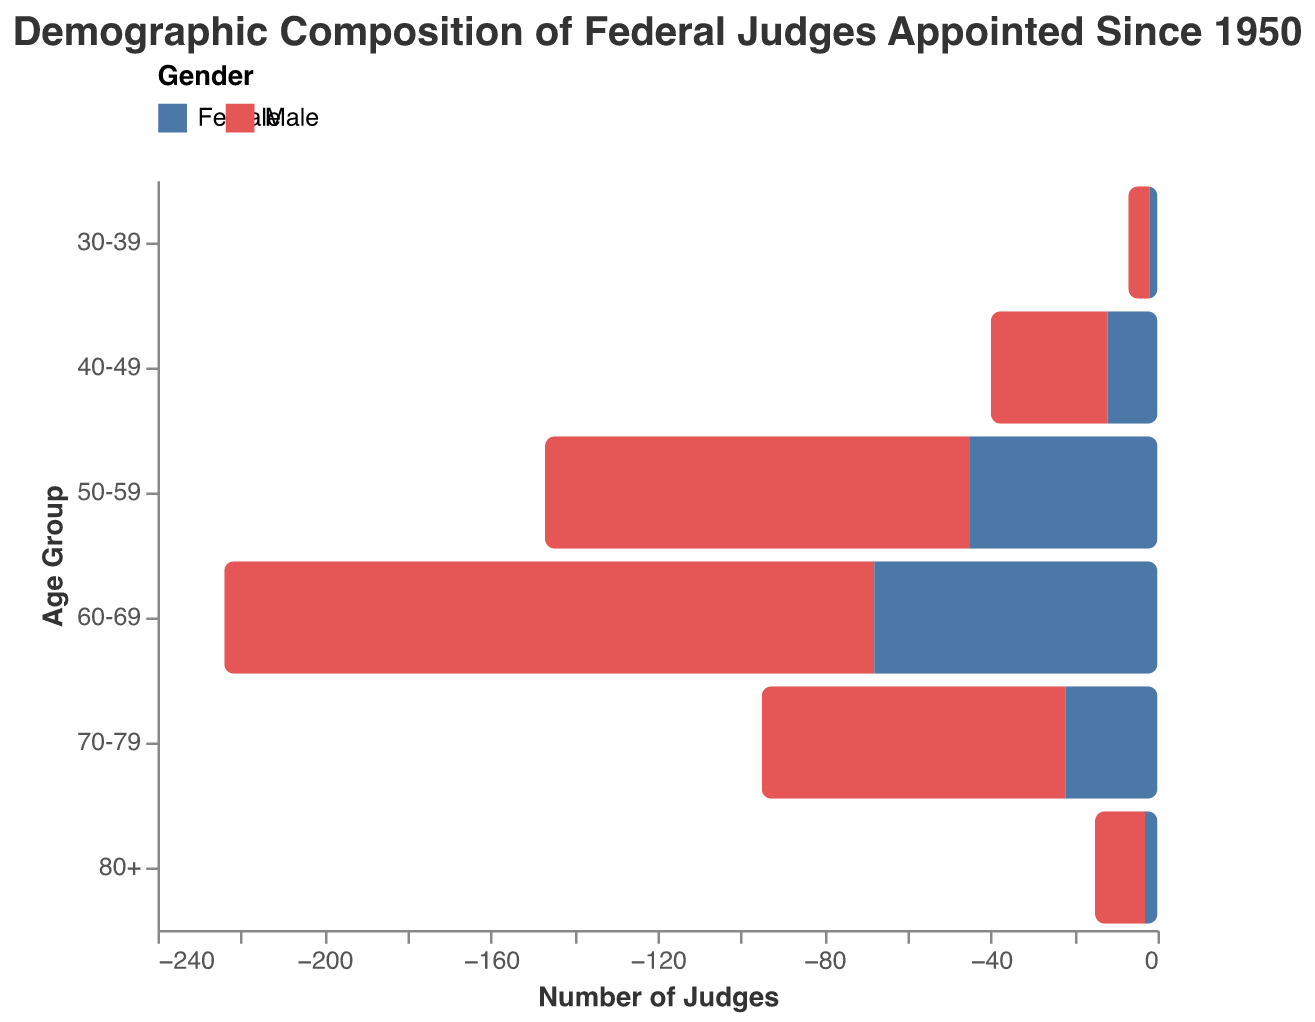What is the title of the figure? The title of the figure is displayed at the top and reads "Demographic Composition of Federal Judges Appointed Since 1950".
Answer: Demographic Composition of Federal Judges Appointed Since 1950 What does the color represent in the figure? The colors represent the gender of the judges, with one color for males and another color for females, as indicated by the legend.
Answer: Gender Which age group has the highest number of male judges? The age group "60-69" shows the longest bar for males, indicating the highest number of male judges in this age range.
Answer: 60-69 Which age group has the smallest gender disparity in the number of judges? By comparing the difference between male and female bars within each age group, the age group "30-39" shows the smallest disparity.
Answer: 30-39 In which age group is the gender imbalance most pronounced? The age group "60-69" has the largest difference between male and female judges, as seen by the significant difference in bar lengths.
Answer: 60-69 How many female judges are in the "80+" age group? The "80+" age group has a bar length corresponding to 3 female judges.
Answer: 3 Compare the number of male and female judges in the "40-49" age group. The number of male judges (28) is greater than the number of female judges (12) in the "40-49" age group.
Answer: Males > Females What is the combined total of female judges across all age groups? Sum of the female values for all age groups: 2 + 12 + 45 + 68 + 22 + 3 = 152
Answer: 152 In which age group are there more female judges than male judges? By evaluating the bars' lengths, in no age group are there more female judges than male judges.
Answer: None 